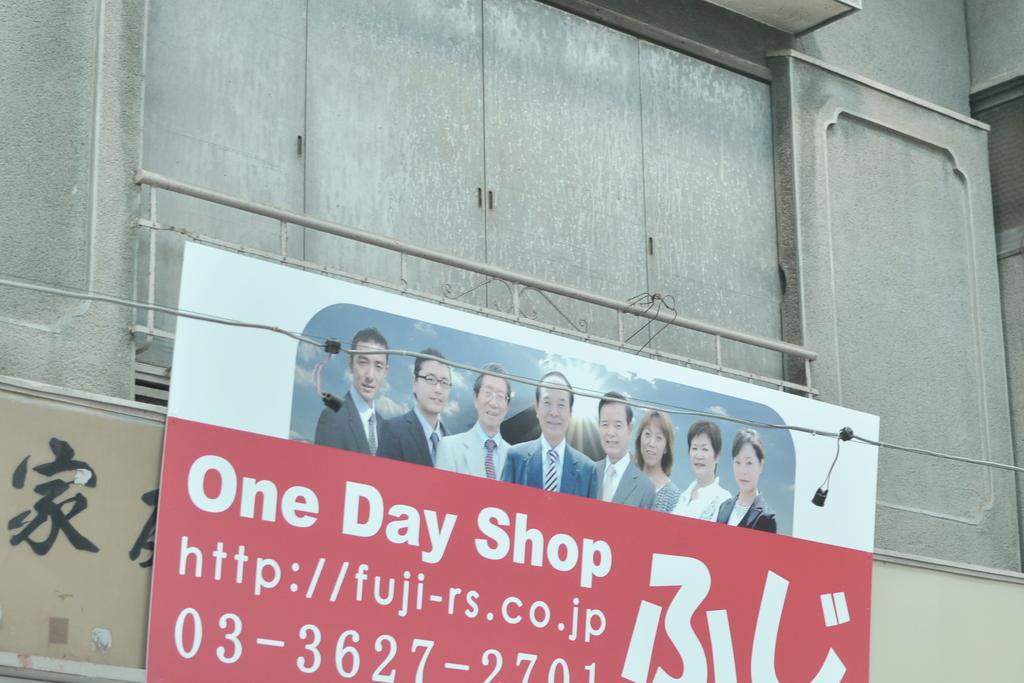How many days is this shop?
Offer a terse response. One. 